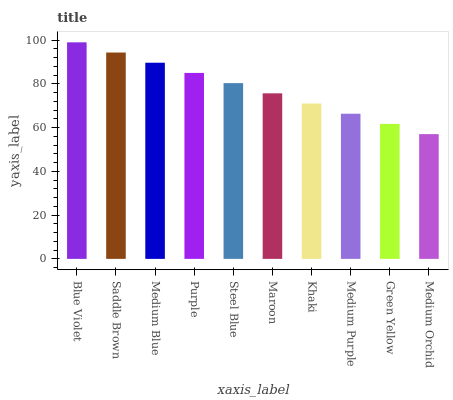Is Medium Orchid the minimum?
Answer yes or no. Yes. Is Blue Violet the maximum?
Answer yes or no. Yes. Is Saddle Brown the minimum?
Answer yes or no. No. Is Saddle Brown the maximum?
Answer yes or no. No. Is Blue Violet greater than Saddle Brown?
Answer yes or no. Yes. Is Saddle Brown less than Blue Violet?
Answer yes or no. Yes. Is Saddle Brown greater than Blue Violet?
Answer yes or no. No. Is Blue Violet less than Saddle Brown?
Answer yes or no. No. Is Steel Blue the high median?
Answer yes or no. Yes. Is Maroon the low median?
Answer yes or no. Yes. Is Maroon the high median?
Answer yes or no. No. Is Steel Blue the low median?
Answer yes or no. No. 